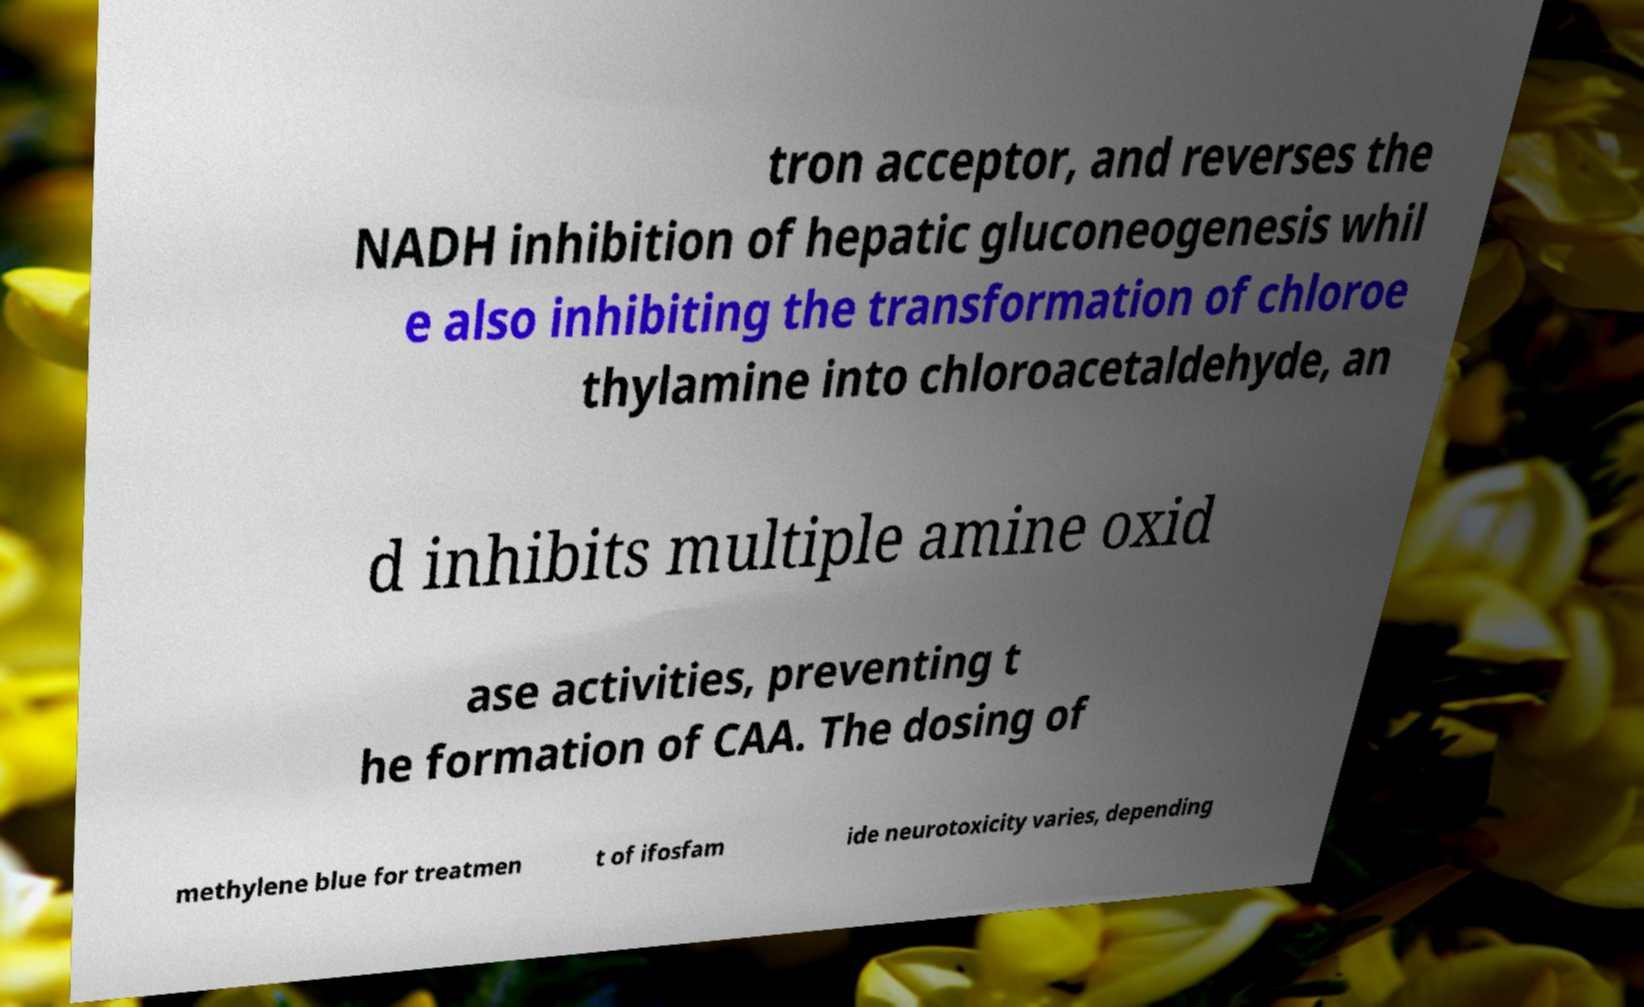For documentation purposes, I need the text within this image transcribed. Could you provide that? tron acceptor, and reverses the NADH inhibition of hepatic gluconeogenesis whil e also inhibiting the transformation of chloroe thylamine into chloroacetaldehyde, an d inhibits multiple amine oxid ase activities, preventing t he formation of CAA. The dosing of methylene blue for treatmen t of ifosfam ide neurotoxicity varies, depending 